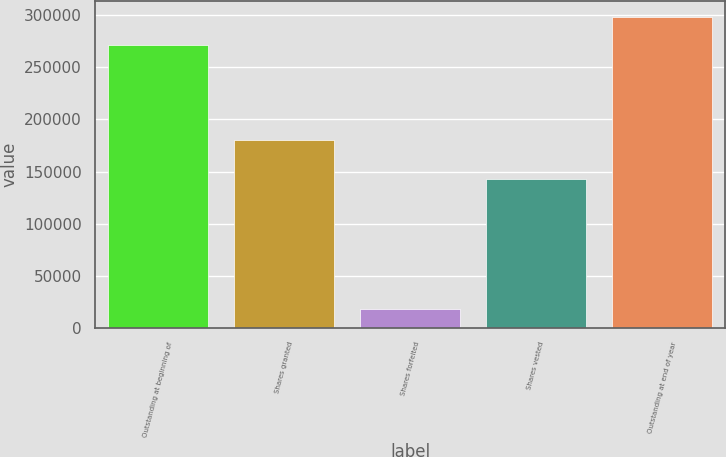Convert chart. <chart><loc_0><loc_0><loc_500><loc_500><bar_chart><fcel>Outstanding at beginning of<fcel>Shares granted<fcel>Shares forfeited<fcel>Shares vested<fcel>Outstanding at end of year<nl><fcel>271031<fcel>180383<fcel>18290<fcel>142572<fcel>298257<nl></chart> 